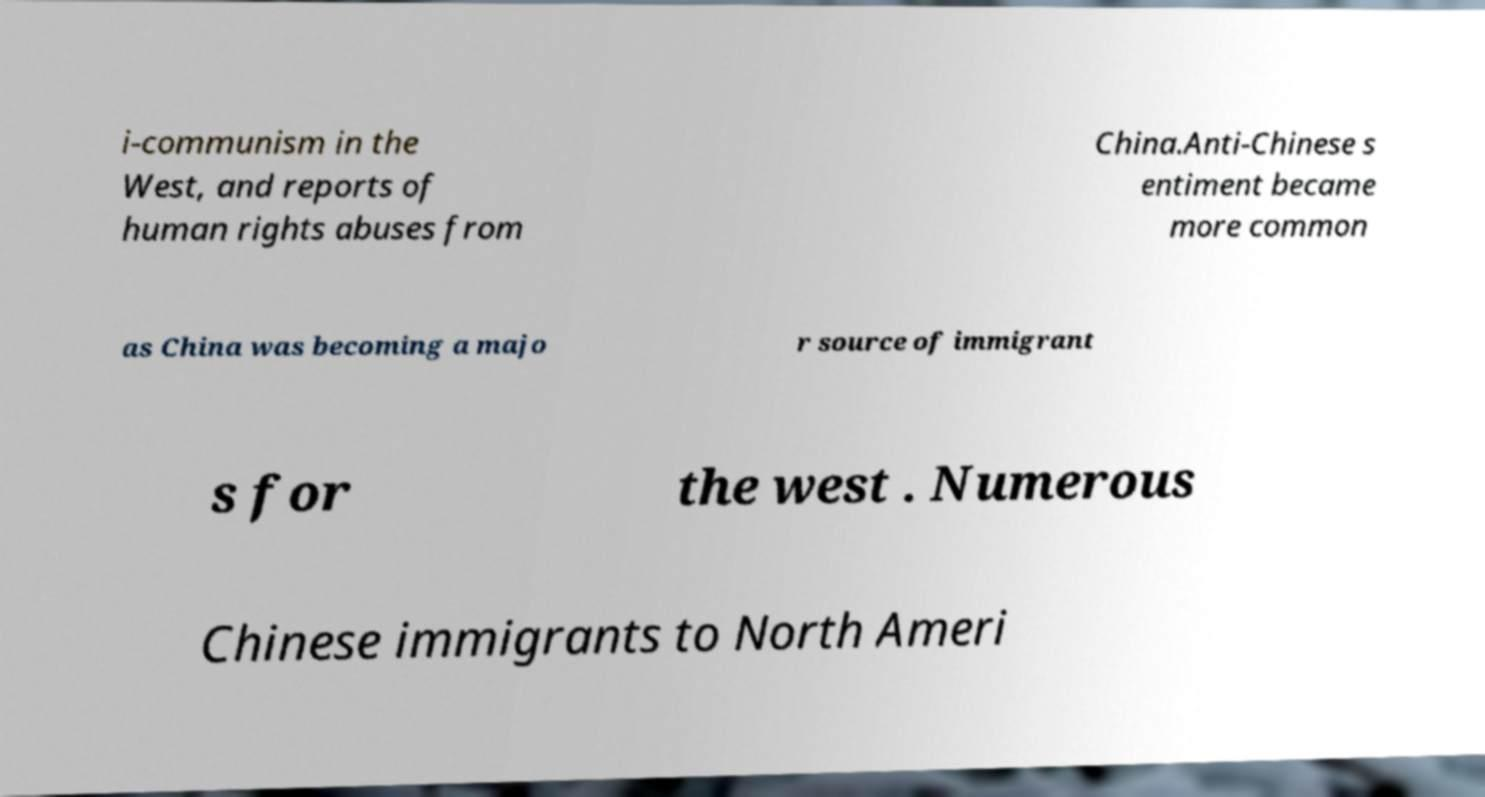Can you read and provide the text displayed in the image?This photo seems to have some interesting text. Can you extract and type it out for me? i-communism in the West, and reports of human rights abuses from China.Anti-Chinese s entiment became more common as China was becoming a majo r source of immigrant s for the west . Numerous Chinese immigrants to North Ameri 